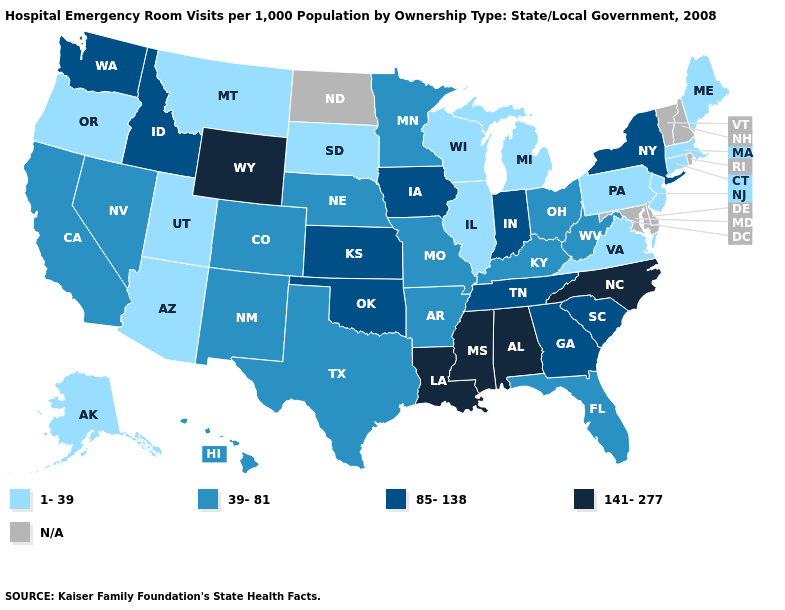Name the states that have a value in the range N/A?
Be succinct. Delaware, Maryland, New Hampshire, North Dakota, Rhode Island, Vermont. Does Florida have the highest value in the South?
Give a very brief answer. No. Name the states that have a value in the range N/A?
Answer briefly. Delaware, Maryland, New Hampshire, North Dakota, Rhode Island, Vermont. What is the value of Alaska?
Keep it brief. 1-39. Among the states that border North Dakota , which have the highest value?
Answer briefly. Minnesota. Does Nevada have the highest value in the USA?
Answer briefly. No. Name the states that have a value in the range 85-138?
Give a very brief answer. Georgia, Idaho, Indiana, Iowa, Kansas, New York, Oklahoma, South Carolina, Tennessee, Washington. Name the states that have a value in the range 39-81?
Give a very brief answer. Arkansas, California, Colorado, Florida, Hawaii, Kentucky, Minnesota, Missouri, Nebraska, Nevada, New Mexico, Ohio, Texas, West Virginia. What is the highest value in the USA?
Quick response, please. 141-277. Name the states that have a value in the range 1-39?
Write a very short answer. Alaska, Arizona, Connecticut, Illinois, Maine, Massachusetts, Michigan, Montana, New Jersey, Oregon, Pennsylvania, South Dakota, Utah, Virginia, Wisconsin. What is the value of Tennessee?
Short answer required. 85-138. Which states hav the highest value in the Northeast?
Keep it brief. New York. Name the states that have a value in the range 85-138?
Be succinct. Georgia, Idaho, Indiana, Iowa, Kansas, New York, Oklahoma, South Carolina, Tennessee, Washington. Name the states that have a value in the range 39-81?
Keep it brief. Arkansas, California, Colorado, Florida, Hawaii, Kentucky, Minnesota, Missouri, Nebraska, Nevada, New Mexico, Ohio, Texas, West Virginia. 